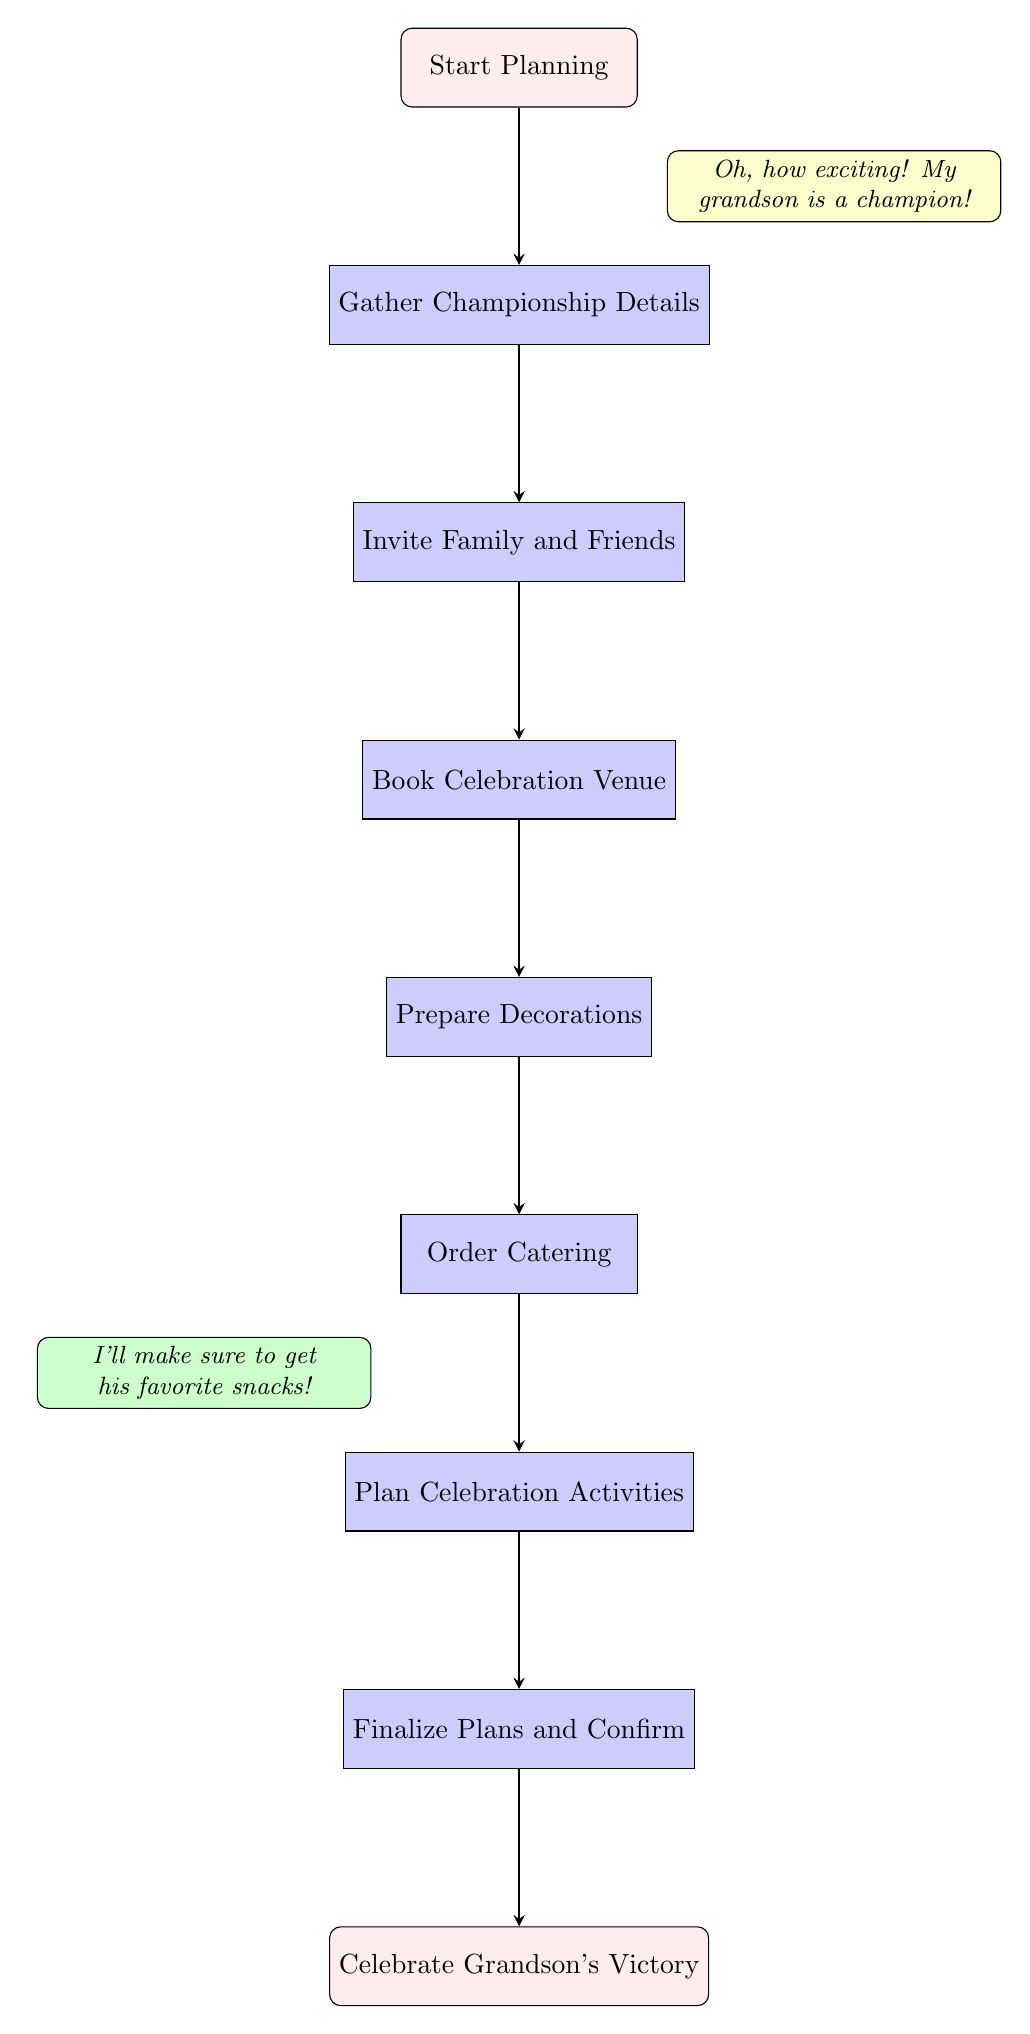What is the first step in the planning process? The first step in the diagram is labeled "Start Planning," which indicates the beginning of the process.
Answer: Start Planning How many steps are there in total to celebrate the grandson's victory? The diagram outlines eight distinct steps from "Start Planning" to "Celebrate Grandson's Victory." These steps are sequential, each leading into the next.
Answer: Eight Which step comes after preparing decorations? The step that follows "Prepare Decorations" is "Order Catering," according to the sequence shown in the diagram.
Answer: Order Catering What node comes before inviting family and friends? The node directly preceding "Invite Family and Friends" is "Gather Championship Details," showing the order of operations required for planning.
Answer: Gather Championship Details Name one activity listed in the steps that will take place before celebrating. One activity that takes place before the final celebration is "Plan Celebration Activities," which is essential before moving to the celebration stage.
Answer: Plan Celebration Activities What type of venue is to be booked according to the chart? While the diagram specifies "Book Celebration Venue," it does not detail the specific type of venue, only indicating that this is a necessary step.
Answer: Celebration Venue Which two nodes are connected directly by an arrow before finalizing plans? The nodes "Plan Celebration Activities" and "Finalize Plans and Confirm" are connected directly by an arrow, indicating the flow from planning activities to finalizing.
Answer: Plan Celebration Activities and Finalize Plans and Confirm What confirms the completion of the planning process? The final step labeled "Celebrate Grandson's Victory" confirms that all previous steps have led to the successful completion of the planning process.
Answer: Celebrate Grandson's Victory 